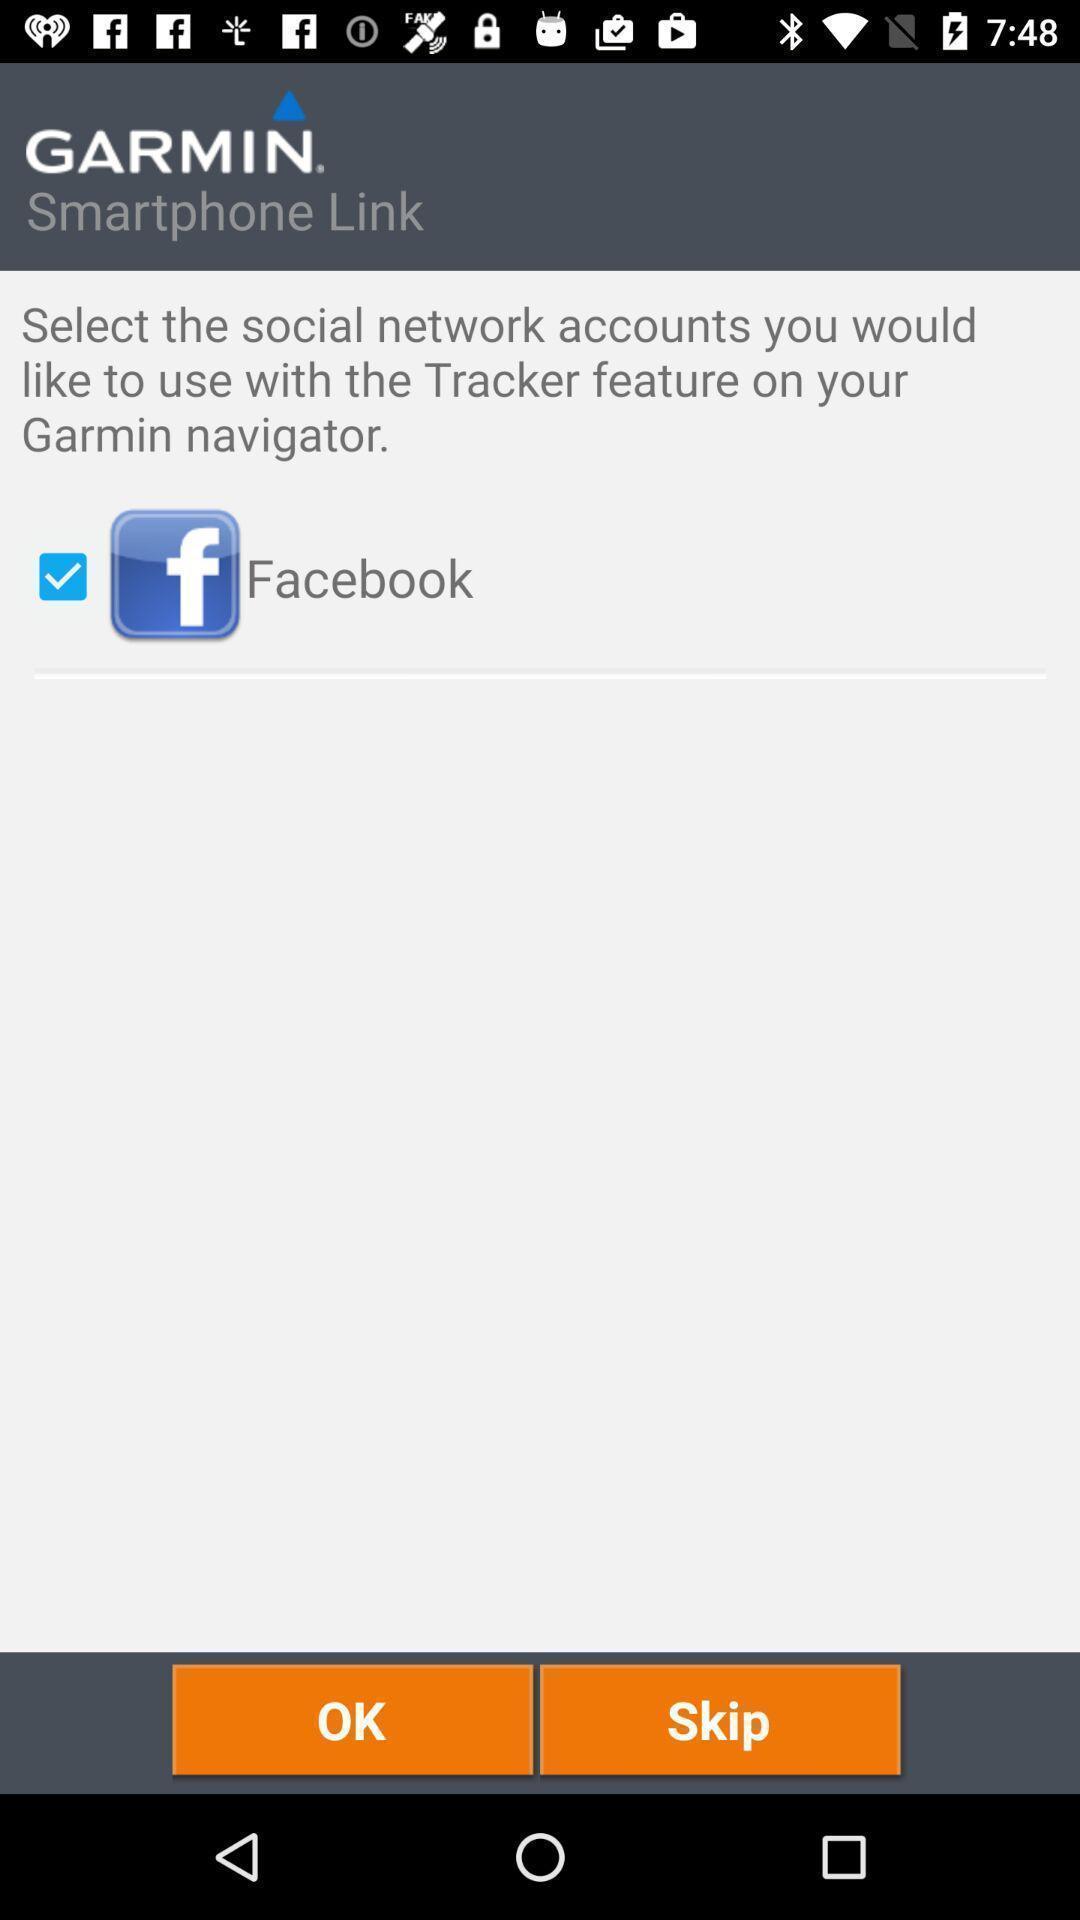Explain what's happening in this screen capture. Selecting the social network for the further process in application. 